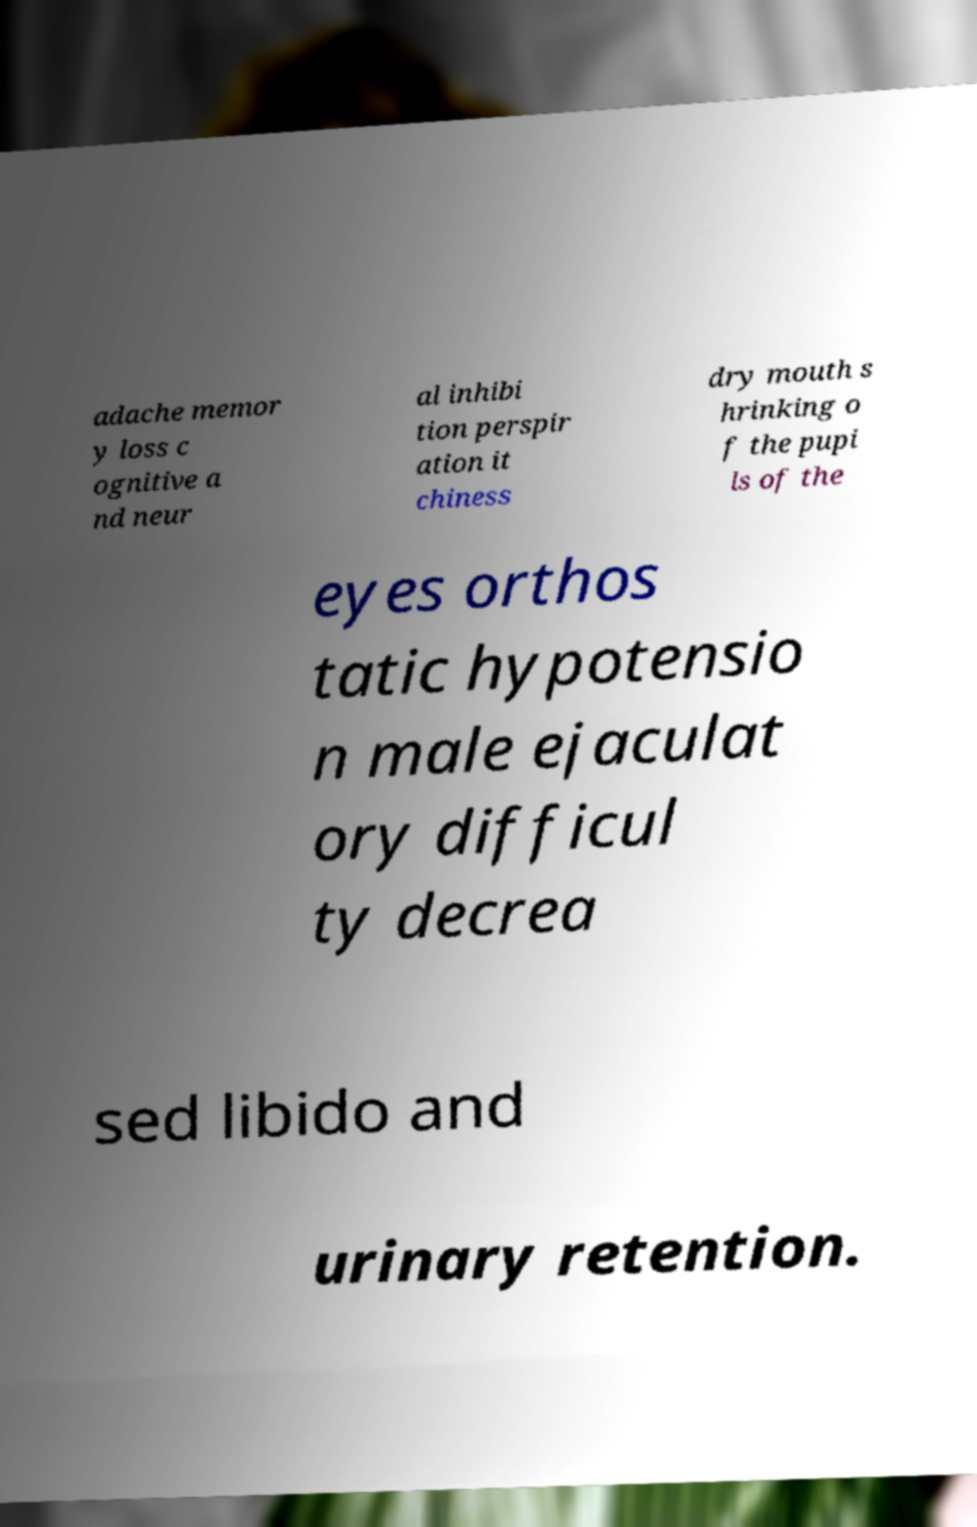Could you extract and type out the text from this image? adache memor y loss c ognitive a nd neur al inhibi tion perspir ation it chiness dry mouth s hrinking o f the pupi ls of the eyes orthos tatic hypotensio n male ejaculat ory difficul ty decrea sed libido and urinary retention. 